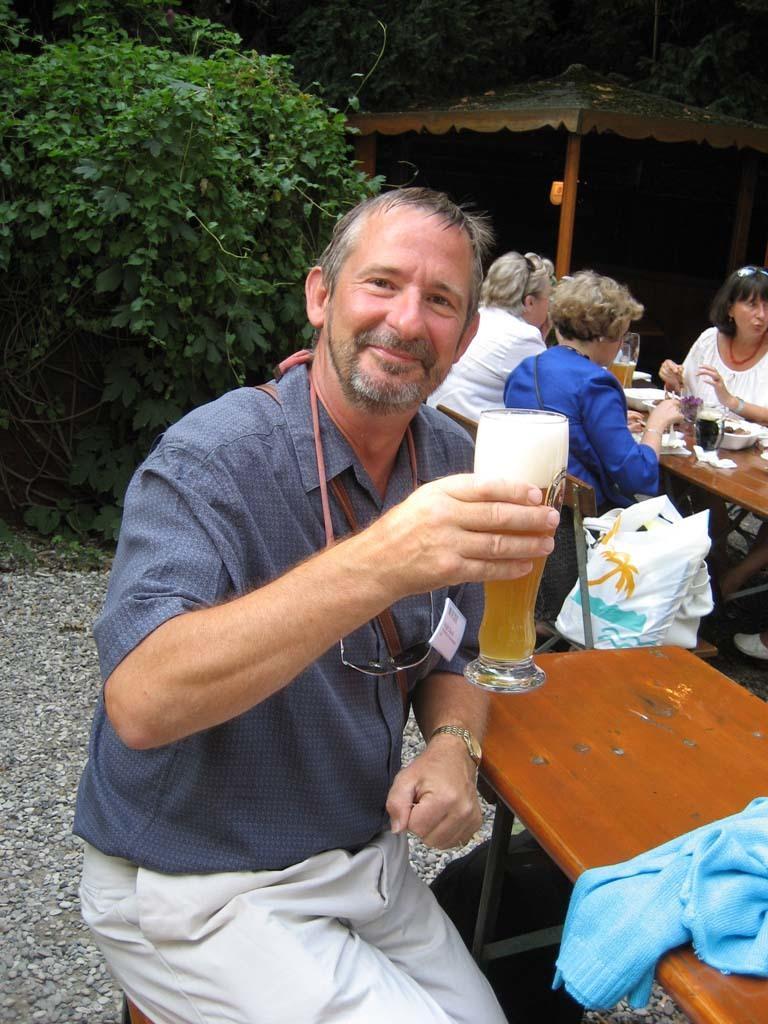Please provide a concise description of this image. This man is sitting on a chair and holding a glass and smiling. We can able to see persons are sitting on a chair. On this tables there are glasses, bowls and paper. Far there is a plant and trees. 